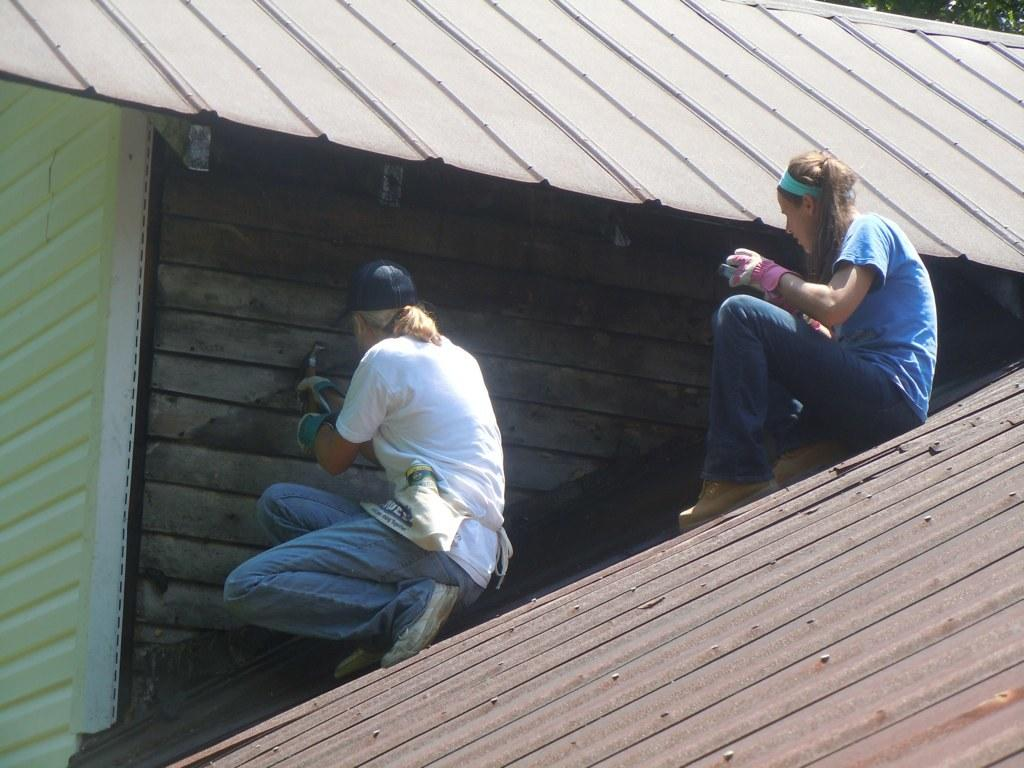What are the two people in the image doing? There is a man and a lady sitting on a roof in the image. What object is the man holding in the image? The man is holding a hammer in the image. What type of structure is visible in the image? There is a roof and a wall present in the image. What type of question is being asked by the lady in the image? There is no indication in the image that the lady is asking a question. What town is visible in the background of the image? There is no town visible in the image; it only shows a man, a lady, a roof, and a wall. 